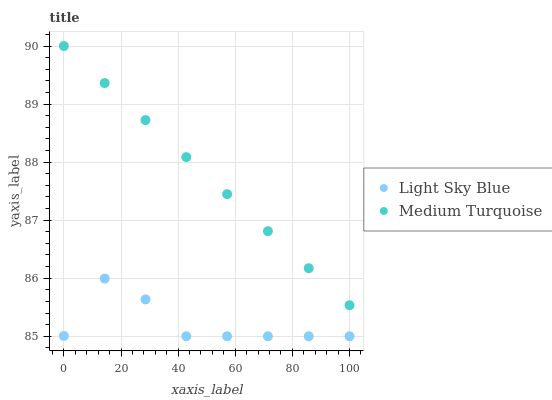Does Light Sky Blue have the minimum area under the curve?
Answer yes or no. Yes. Does Medium Turquoise have the maximum area under the curve?
Answer yes or no. Yes. Does Medium Turquoise have the minimum area under the curve?
Answer yes or no. No. Is Medium Turquoise the smoothest?
Answer yes or no. Yes. Is Light Sky Blue the roughest?
Answer yes or no. Yes. Is Medium Turquoise the roughest?
Answer yes or no. No. Does Light Sky Blue have the lowest value?
Answer yes or no. Yes. Does Medium Turquoise have the lowest value?
Answer yes or no. No. Does Medium Turquoise have the highest value?
Answer yes or no. Yes. Is Light Sky Blue less than Medium Turquoise?
Answer yes or no. Yes. Is Medium Turquoise greater than Light Sky Blue?
Answer yes or no. Yes. Does Light Sky Blue intersect Medium Turquoise?
Answer yes or no. No. 